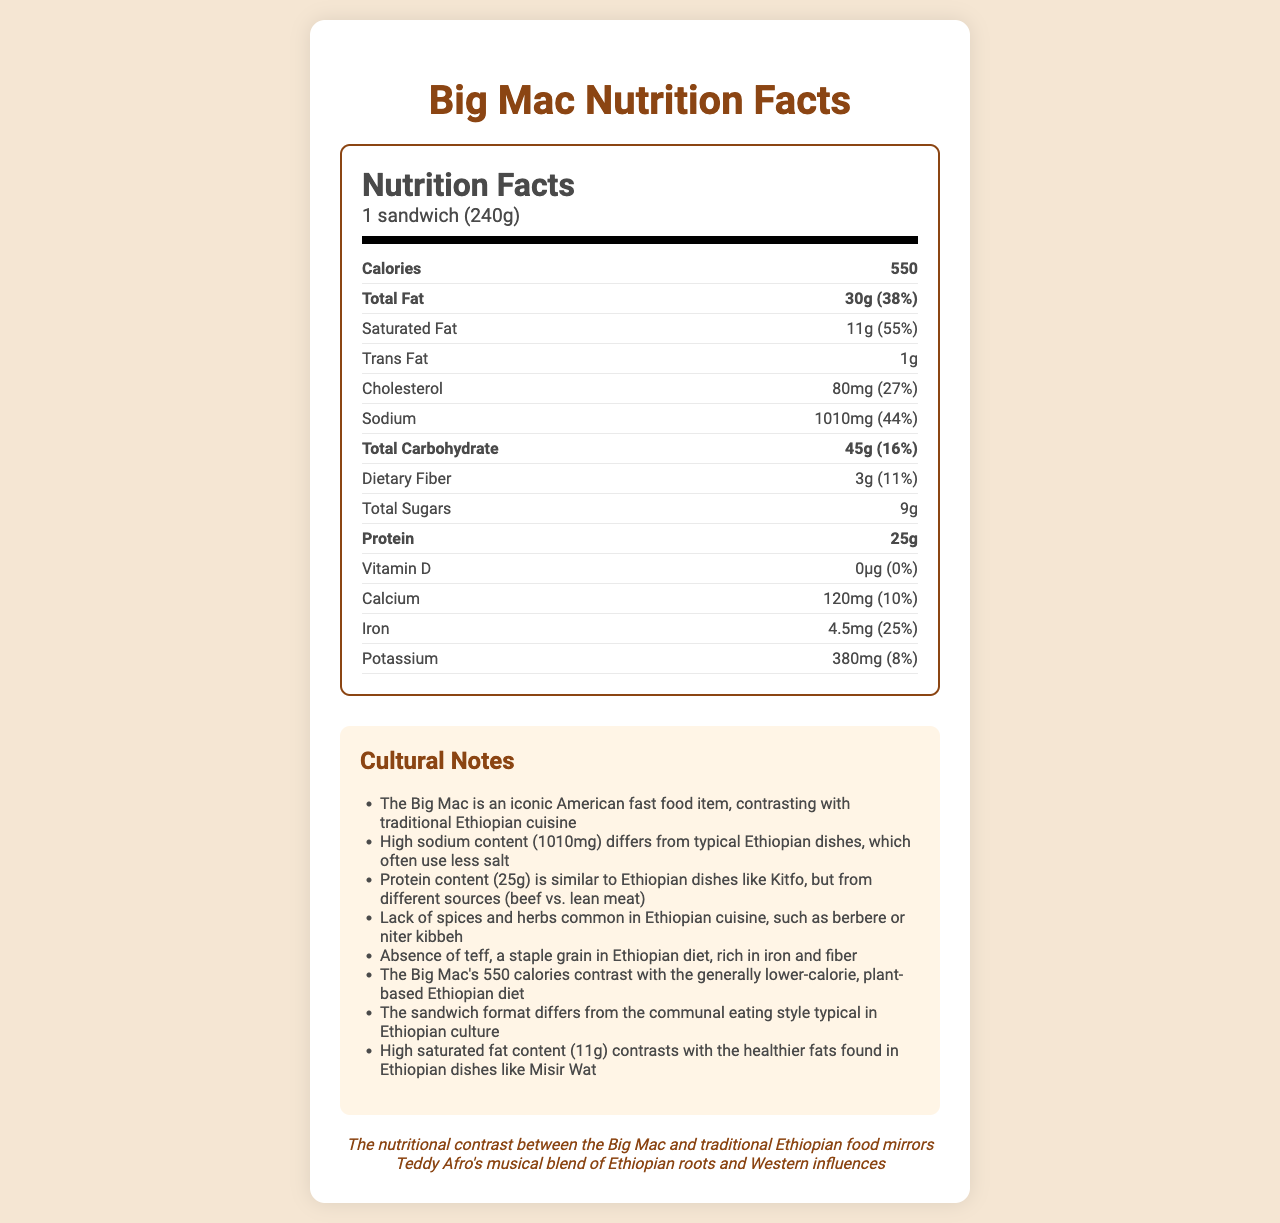what is the food item described in the document? The title of the document specifies "Nutrition Facts: Big Mac".
Answer: Big Mac how many calories are in one Big Mac sandwich? The document lists the calories as 550.
Answer: 550 what is the serving size of the Big Mac? The serving size is clearly mentioned in the nutrition facts section.
Answer: 1 sandwich (240g) which nutrient has the highest daily value percentage? The saturated fat has a daily value of 55%, which is higher than any other nutrient listed.
Answer: Saturated fat (55%) how much protein is in a Big Mac? The nutrition label states that the Big Mac contains 25 grams of protein.
Answer: 25 grams what is the daily value percentage for sodium? The document indicates that the sodium content corresponds to 44% of the daily value.
Answer: 44% what is the vitamin D daily value percentage for a Big Mac? The document shows that vitamin D has a daily value percentage of 0%.
Answer: 0% which of the following nutrients does NOT have a daily value percentage listed: A. Trans Fat B. Total Sugars C. Protein D. All of the above The document does not list daily value percentages for trans fat, total sugars, or protein.
Answer: D. All of the above how much iron does a Big Mac contain in milligrams? The nutrition label states that the iron content is 4.5 milligrams.
Answer: 4.5 milligrams which nutrient has a lower daily value percentage, calcium or potassium? Calcium has a daily value percentage of 10%, while potassium has a daily value percentage of 8%.
Answer: Potassium true or false: A Big Mac contains more dietary fiber than total sugars The Big Mac contains 3 grams of dietary fiber and 9 grams of total sugars, so it has more total sugars.
Answer: False summarize the key differences between the nutritional content of a Big Mac and traditional Ethiopian cuisine The summary describes the contrast between the high-calorie, high-sodium, high-saturated-fat content of the Big Mac and the generally healthier, plant-based, and communal traditional Ethiopian cuisine.
Answer: Traditional Ethiopian cuisine generally has lower calories and saturated fat, typically uses less sodium, and relies more on plant-based ingredients and spices like berbere and niter kibbeh. Unlike the Big Mac, Ethiopian dishes often include teff, a staple grain high in iron and fiber. The document highlights that the Big Mac's format and high sodium and saturated fat content contrast with the healthier fats and communal eating style of Ethiopian dishes. what is missing from the Big Mac that is commonly found in Ethiopian dishes, as noted in the document? The cultural notes section points out that the Big Mac lacks spices and herbs such as berbere and niter kibbeh, which are common in Ethiopian cuisine.
Answer: Spices and herbs like berbere and niter kibbeh does the Big Mac contain teff? The document clearly mentions the absence of teff in a Big Mac.
Answer: No how does the protein content of a Big Mac compare to Ethiopian dishes like Kitfo? The cultural notes highlight that while the protein content is similar to Kitfo, the sources differ; a Big Mac uses beef, while Kitfo typically uses lean meats.
Answer: Similar in amount but different sources (beef vs. lean meat) does the Big Mac's high-calorie content align with the traditional Ethiopian diet? The document mentions that the Big Mac's 550 calories contrast with the generally lower-calorie, plant-based Ethiopian diet.
Answer: No what is the significant comparison made between Teddy Afro's musical style and the Big Mac's nutritional content? The document draws a parallel between the nutritional differences of the Big Mac and traditional Ethiopian food to Teddy Afro's musical blend of Ethiopian and Western influences.
Answer: The nutritional contrast mirrors Teddy Afro's blend of Ethiopian roots and Western influences how much total carbohydrate does a Big Mac contain in grams? The nutrition label specifies that a Big Mac contains 45 grams of total carbohydrate.
Answer: 45 grams what is the daily value percentage for dietary fiber in a Big Mac? The daily value percentage for dietary fiber is 11% as mentioned in the nutrition label.
Answer: 11% which ingredient common in Ethiopian cuisine and rich in iron and fiber is absent from the Big Mac? The document notes the absence of teff, a staple grain in the Ethiopian diet, from the Big Mac.
Answer: Teff what does the Big Mac's format differ from in Ethiopian culture? The cultural notes section highlights the difference in the sandwich format of the Big Mac compared to the communal eating style typical in Ethiopian culture.
Answer: Communal eating style what is the cholesterol content in milligrams for one Big Mac? The nutrition label states that the cholesterol content is 80 milligrams.
Answer: 80 milligrams what is the daily value percentage of total fat in a Big Mac? The document lists the daily value percentage for total fat as 38%.
Answer: 38% what information is missing regarding the trans fat content's daily value? The document does not provide the daily value percentage for trans fat, stating it as null.
Answer: Not enough information 